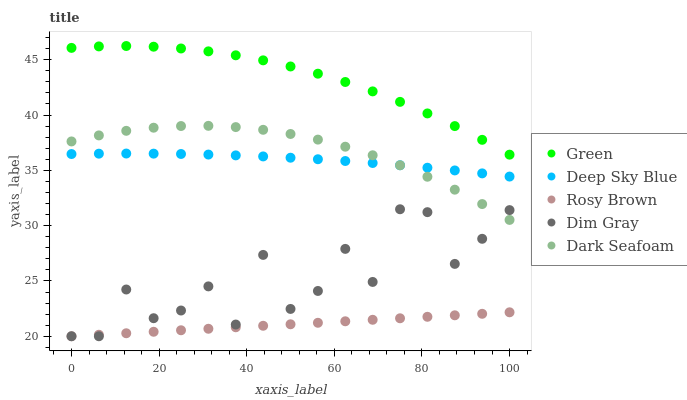Does Rosy Brown have the minimum area under the curve?
Answer yes or no. Yes. Does Green have the maximum area under the curve?
Answer yes or no. Yes. Does Green have the minimum area under the curve?
Answer yes or no. No. Does Rosy Brown have the maximum area under the curve?
Answer yes or no. No. Is Rosy Brown the smoothest?
Answer yes or no. Yes. Is Dim Gray the roughest?
Answer yes or no. Yes. Is Green the smoothest?
Answer yes or no. No. Is Green the roughest?
Answer yes or no. No. Does Dim Gray have the lowest value?
Answer yes or no. Yes. Does Green have the lowest value?
Answer yes or no. No. Does Green have the highest value?
Answer yes or no. Yes. Does Rosy Brown have the highest value?
Answer yes or no. No. Is Dim Gray less than Deep Sky Blue?
Answer yes or no. Yes. Is Dark Seafoam greater than Rosy Brown?
Answer yes or no. Yes. Does Dark Seafoam intersect Deep Sky Blue?
Answer yes or no. Yes. Is Dark Seafoam less than Deep Sky Blue?
Answer yes or no. No. Is Dark Seafoam greater than Deep Sky Blue?
Answer yes or no. No. Does Dim Gray intersect Deep Sky Blue?
Answer yes or no. No. 